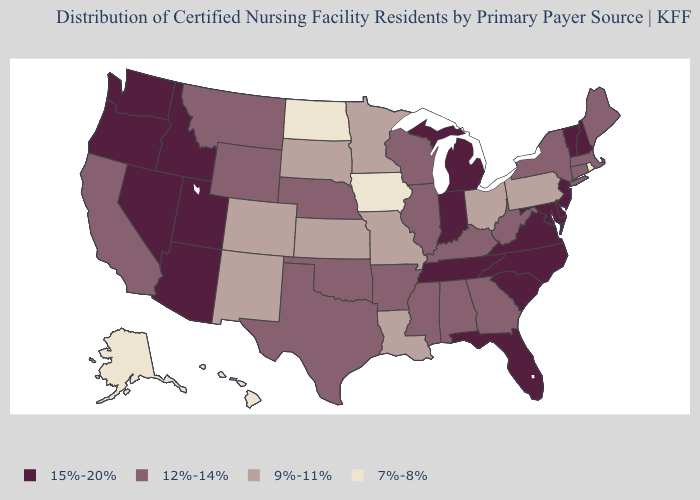Name the states that have a value in the range 12%-14%?
Short answer required. Alabama, Arkansas, California, Connecticut, Georgia, Illinois, Kentucky, Maine, Massachusetts, Mississippi, Montana, Nebraska, New York, Oklahoma, Texas, West Virginia, Wisconsin, Wyoming. Name the states that have a value in the range 15%-20%?
Keep it brief. Arizona, Delaware, Florida, Idaho, Indiana, Maryland, Michigan, Nevada, New Hampshire, New Jersey, North Carolina, Oregon, South Carolina, Tennessee, Utah, Vermont, Virginia, Washington. What is the value of Arizona?
Concise answer only. 15%-20%. What is the value of Illinois?
Write a very short answer. 12%-14%. Does New York have the highest value in the Northeast?
Give a very brief answer. No. Which states hav the highest value in the West?
Concise answer only. Arizona, Idaho, Nevada, Oregon, Utah, Washington. What is the value of Utah?
Write a very short answer. 15%-20%. What is the highest value in the USA?
Write a very short answer. 15%-20%. Among the states that border West Virginia , which have the lowest value?
Answer briefly. Ohio, Pennsylvania. What is the value of Washington?
Answer briefly. 15%-20%. Which states hav the highest value in the West?
Quick response, please. Arizona, Idaho, Nevada, Oregon, Utah, Washington. Does Washington have the highest value in the USA?
Keep it brief. Yes. Which states hav the highest value in the Northeast?
Write a very short answer. New Hampshire, New Jersey, Vermont. What is the value of Oklahoma?
Quick response, please. 12%-14%. 